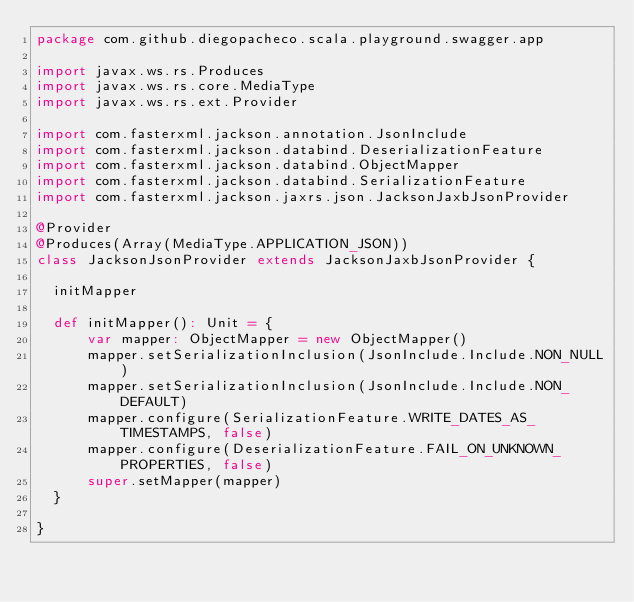<code> <loc_0><loc_0><loc_500><loc_500><_Scala_>package com.github.diegopacheco.scala.playground.swagger.app

import javax.ws.rs.Produces
import javax.ws.rs.core.MediaType
import javax.ws.rs.ext.Provider

import com.fasterxml.jackson.annotation.JsonInclude
import com.fasterxml.jackson.databind.DeserializationFeature
import com.fasterxml.jackson.databind.ObjectMapper
import com.fasterxml.jackson.databind.SerializationFeature
import com.fasterxml.jackson.jaxrs.json.JacksonJaxbJsonProvider

@Provider
@Produces(Array(MediaType.APPLICATION_JSON))
class JacksonJsonProvider extends JacksonJaxbJsonProvider {

  initMapper

  def initMapper(): Unit = {
      var mapper: ObjectMapper = new ObjectMapper()
      mapper.setSerializationInclusion(JsonInclude.Include.NON_NULL)
      mapper.setSerializationInclusion(JsonInclude.Include.NON_DEFAULT)
      mapper.configure(SerializationFeature.WRITE_DATES_AS_TIMESTAMPS, false)
      mapper.configure(DeserializationFeature.FAIL_ON_UNKNOWN_PROPERTIES, false)
      super.setMapper(mapper)
  }

}</code> 